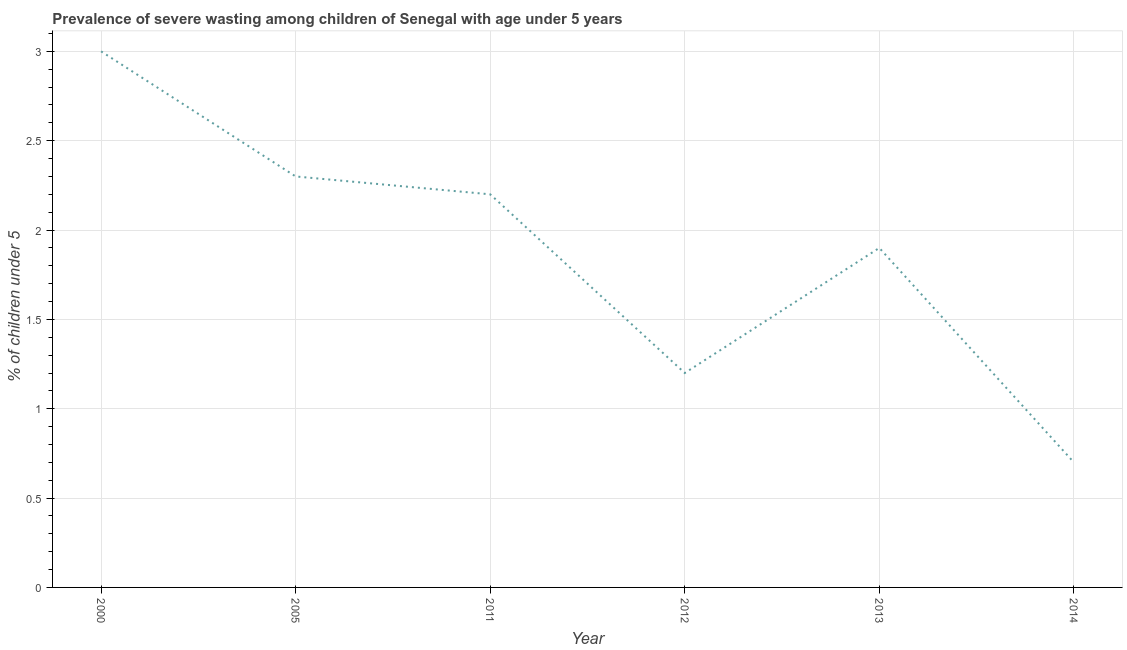What is the prevalence of severe wasting in 2005?
Your answer should be compact. 2.3. Across all years, what is the maximum prevalence of severe wasting?
Your answer should be very brief. 3. Across all years, what is the minimum prevalence of severe wasting?
Provide a succinct answer. 0.7. In which year was the prevalence of severe wasting maximum?
Give a very brief answer. 2000. In which year was the prevalence of severe wasting minimum?
Provide a short and direct response. 2014. What is the sum of the prevalence of severe wasting?
Keep it short and to the point. 11.3. What is the difference between the prevalence of severe wasting in 2000 and 2013?
Give a very brief answer. 1.1. What is the average prevalence of severe wasting per year?
Provide a succinct answer. 1.88. What is the median prevalence of severe wasting?
Your answer should be very brief. 2.05. Do a majority of the years between 2013 and 2014 (inclusive) have prevalence of severe wasting greater than 1.3 %?
Ensure brevity in your answer.  No. What is the ratio of the prevalence of severe wasting in 2005 to that in 2011?
Your response must be concise. 1.05. What is the difference between the highest and the second highest prevalence of severe wasting?
Offer a terse response. 0.7. Is the sum of the prevalence of severe wasting in 2000 and 2005 greater than the maximum prevalence of severe wasting across all years?
Offer a terse response. Yes. What is the difference between the highest and the lowest prevalence of severe wasting?
Your response must be concise. 2.3. Does the prevalence of severe wasting monotonically increase over the years?
Offer a terse response. No. How many lines are there?
Ensure brevity in your answer.  1. Are the values on the major ticks of Y-axis written in scientific E-notation?
Make the answer very short. No. Does the graph contain any zero values?
Your response must be concise. No. What is the title of the graph?
Offer a very short reply. Prevalence of severe wasting among children of Senegal with age under 5 years. What is the label or title of the X-axis?
Keep it short and to the point. Year. What is the label or title of the Y-axis?
Offer a very short reply.  % of children under 5. What is the  % of children under 5 in 2005?
Offer a terse response. 2.3. What is the  % of children under 5 of 2011?
Provide a succinct answer. 2.2. What is the  % of children under 5 in 2012?
Keep it short and to the point. 1.2. What is the  % of children under 5 of 2013?
Offer a terse response. 1.9. What is the  % of children under 5 in 2014?
Give a very brief answer. 0.7. What is the difference between the  % of children under 5 in 2000 and 2005?
Give a very brief answer. 0.7. What is the difference between the  % of children under 5 in 2000 and 2013?
Give a very brief answer. 1.1. What is the difference between the  % of children under 5 in 2000 and 2014?
Ensure brevity in your answer.  2.3. What is the difference between the  % of children under 5 in 2005 and 2012?
Keep it short and to the point. 1.1. What is the difference between the  % of children under 5 in 2005 and 2013?
Keep it short and to the point. 0.4. What is the difference between the  % of children under 5 in 2011 and 2012?
Offer a very short reply. 1. What is the difference between the  % of children under 5 in 2011 and 2013?
Provide a succinct answer. 0.3. What is the difference between the  % of children under 5 in 2011 and 2014?
Offer a terse response. 1.5. What is the ratio of the  % of children under 5 in 2000 to that in 2005?
Provide a short and direct response. 1.3. What is the ratio of the  % of children under 5 in 2000 to that in 2011?
Your response must be concise. 1.36. What is the ratio of the  % of children under 5 in 2000 to that in 2013?
Your response must be concise. 1.58. What is the ratio of the  % of children under 5 in 2000 to that in 2014?
Your answer should be very brief. 4.29. What is the ratio of the  % of children under 5 in 2005 to that in 2011?
Your response must be concise. 1.04. What is the ratio of the  % of children under 5 in 2005 to that in 2012?
Your response must be concise. 1.92. What is the ratio of the  % of children under 5 in 2005 to that in 2013?
Your answer should be very brief. 1.21. What is the ratio of the  % of children under 5 in 2005 to that in 2014?
Provide a short and direct response. 3.29. What is the ratio of the  % of children under 5 in 2011 to that in 2012?
Your response must be concise. 1.83. What is the ratio of the  % of children under 5 in 2011 to that in 2013?
Ensure brevity in your answer.  1.16. What is the ratio of the  % of children under 5 in 2011 to that in 2014?
Your response must be concise. 3.14. What is the ratio of the  % of children under 5 in 2012 to that in 2013?
Keep it short and to the point. 0.63. What is the ratio of the  % of children under 5 in 2012 to that in 2014?
Keep it short and to the point. 1.71. What is the ratio of the  % of children under 5 in 2013 to that in 2014?
Your answer should be very brief. 2.71. 